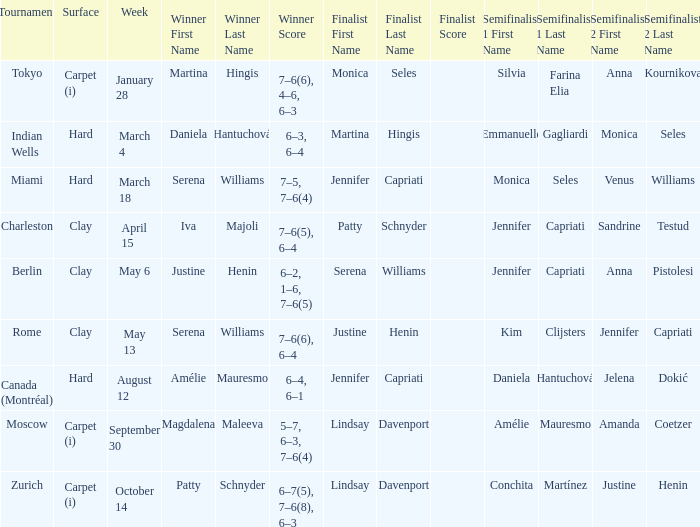What week was the finalist Martina Hingis? March 4. 